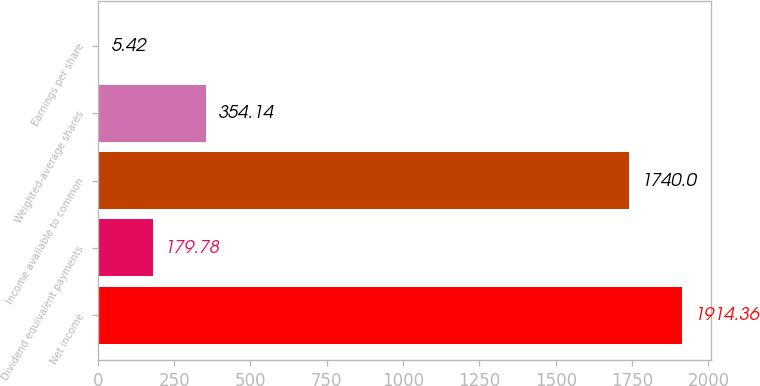Convert chart to OTSL. <chart><loc_0><loc_0><loc_500><loc_500><bar_chart><fcel>Net income<fcel>Dividend equivalent payments<fcel>Income available to common<fcel>Weighted-average shares<fcel>Earnings per share<nl><fcel>1914.36<fcel>179.78<fcel>1740<fcel>354.14<fcel>5.42<nl></chart> 